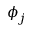Convert formula to latex. <formula><loc_0><loc_0><loc_500><loc_500>\phi _ { j }</formula> 